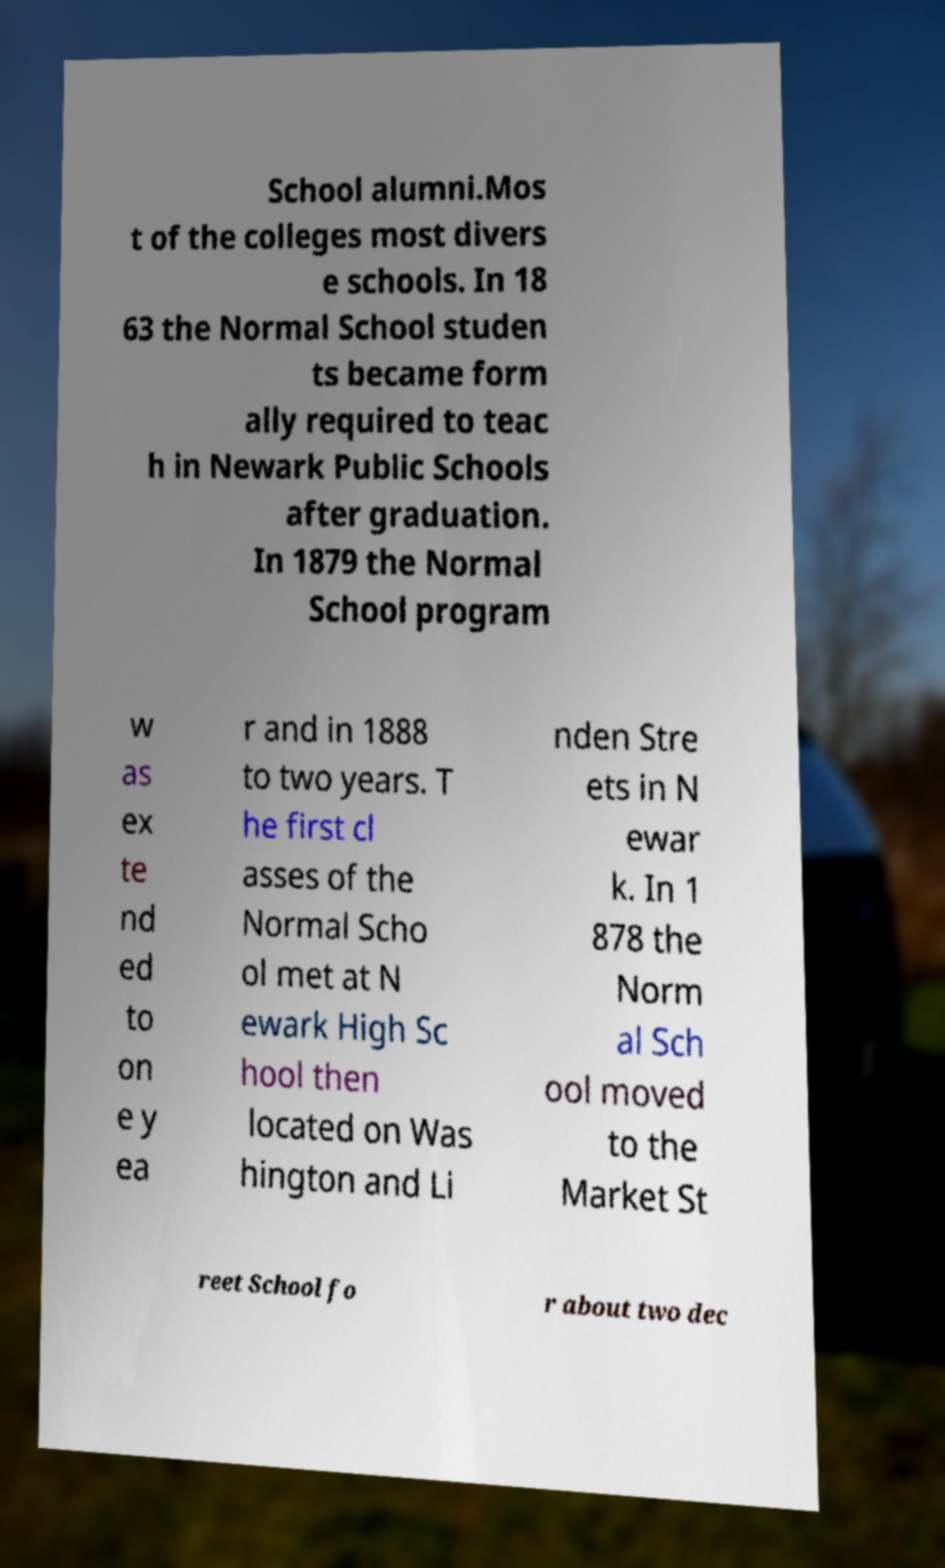Please read and relay the text visible in this image. What does it say? School alumni.Mos t of the colleges most divers e schools. In 18 63 the Normal School studen ts became form ally required to teac h in Newark Public Schools after graduation. In 1879 the Normal School program w as ex te nd ed to on e y ea r and in 1888 to two years. T he first cl asses of the Normal Scho ol met at N ewark High Sc hool then located on Was hington and Li nden Stre ets in N ewar k. In 1 878 the Norm al Sch ool moved to the Market St reet School fo r about two dec 